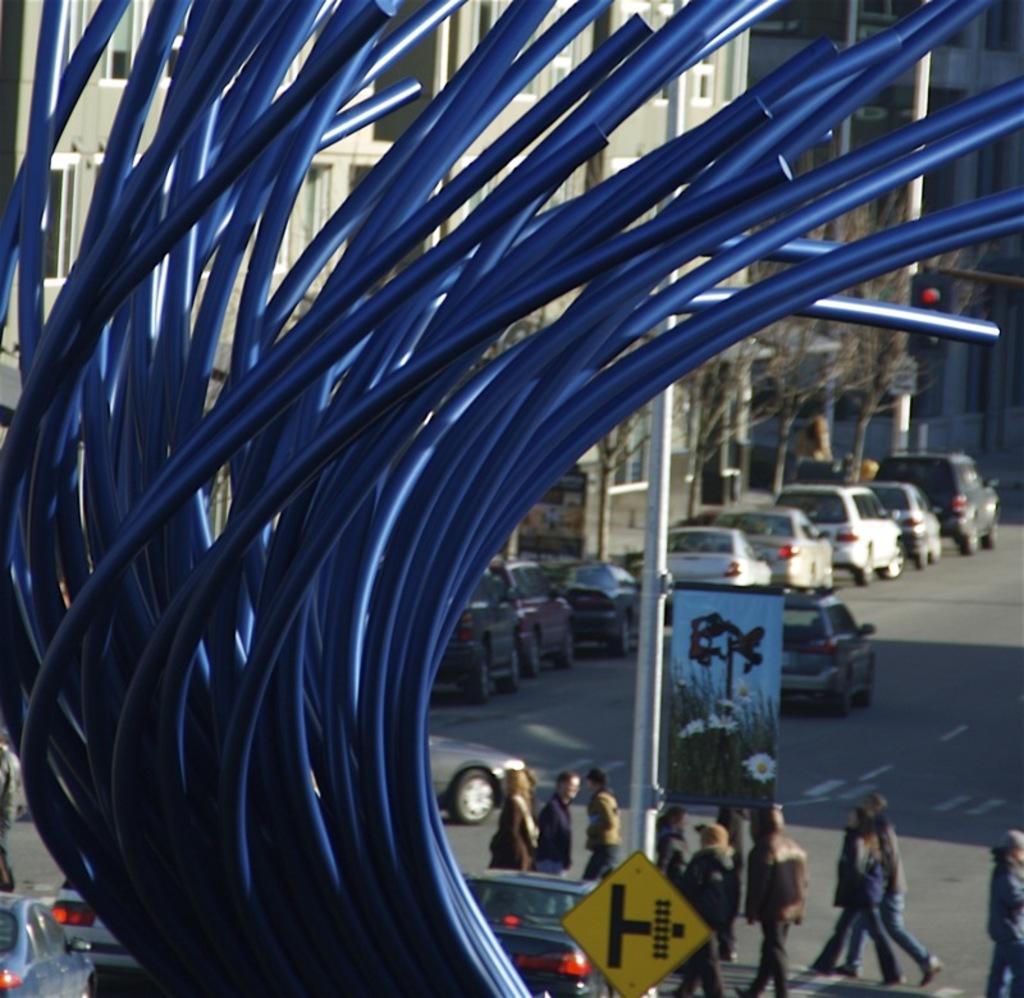Can you describe this image briefly? In this image I can see few buildings, windows, trees, traffic signals, poles, signboards, vehicles and few people. In front I can see the blue color object. 